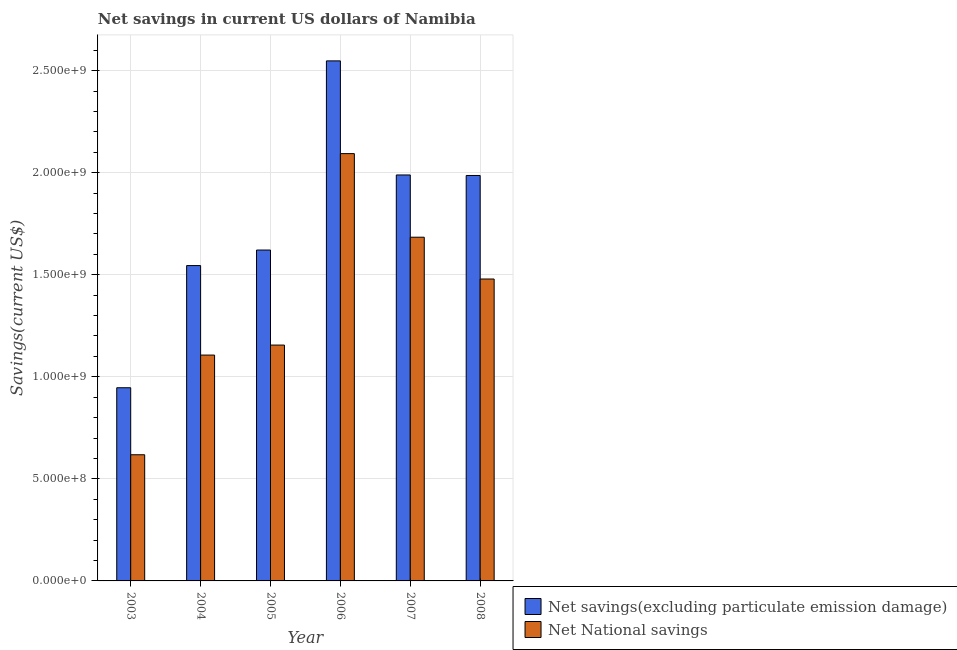How many different coloured bars are there?
Your answer should be compact. 2. Are the number of bars per tick equal to the number of legend labels?
Provide a succinct answer. Yes. How many bars are there on the 5th tick from the right?
Keep it short and to the point. 2. What is the net savings(excluding particulate emission damage) in 2008?
Your response must be concise. 1.99e+09. Across all years, what is the maximum net savings(excluding particulate emission damage)?
Your response must be concise. 2.55e+09. Across all years, what is the minimum net savings(excluding particulate emission damage)?
Give a very brief answer. 9.46e+08. What is the total net national savings in the graph?
Provide a short and direct response. 8.14e+09. What is the difference between the net national savings in 2006 and that in 2008?
Give a very brief answer. 6.14e+08. What is the difference between the net savings(excluding particulate emission damage) in 2008 and the net national savings in 2006?
Your response must be concise. -5.61e+08. What is the average net national savings per year?
Your response must be concise. 1.36e+09. In the year 2003, what is the difference between the net national savings and net savings(excluding particulate emission damage)?
Ensure brevity in your answer.  0. What is the ratio of the net national savings in 2005 to that in 2006?
Provide a short and direct response. 0.55. Is the difference between the net savings(excluding particulate emission damage) in 2003 and 2007 greater than the difference between the net national savings in 2003 and 2007?
Your answer should be very brief. No. What is the difference between the highest and the second highest net national savings?
Offer a very short reply. 4.09e+08. What is the difference between the highest and the lowest net national savings?
Offer a terse response. 1.48e+09. In how many years, is the net national savings greater than the average net national savings taken over all years?
Provide a succinct answer. 3. Is the sum of the net savings(excluding particulate emission damage) in 2007 and 2008 greater than the maximum net national savings across all years?
Make the answer very short. Yes. What does the 1st bar from the left in 2006 represents?
Provide a succinct answer. Net savings(excluding particulate emission damage). What does the 1st bar from the right in 2007 represents?
Make the answer very short. Net National savings. Are all the bars in the graph horizontal?
Keep it short and to the point. No. Are the values on the major ticks of Y-axis written in scientific E-notation?
Your answer should be compact. Yes. Does the graph contain any zero values?
Provide a short and direct response. No. What is the title of the graph?
Your response must be concise. Net savings in current US dollars of Namibia. Does "Food and tobacco" appear as one of the legend labels in the graph?
Your answer should be compact. No. What is the label or title of the Y-axis?
Provide a succinct answer. Savings(current US$). What is the Savings(current US$) of Net savings(excluding particulate emission damage) in 2003?
Your answer should be compact. 9.46e+08. What is the Savings(current US$) in Net National savings in 2003?
Your answer should be very brief. 6.18e+08. What is the Savings(current US$) of Net savings(excluding particulate emission damage) in 2004?
Offer a very short reply. 1.54e+09. What is the Savings(current US$) in Net National savings in 2004?
Your answer should be compact. 1.11e+09. What is the Savings(current US$) in Net savings(excluding particulate emission damage) in 2005?
Your response must be concise. 1.62e+09. What is the Savings(current US$) of Net National savings in 2005?
Your answer should be compact. 1.16e+09. What is the Savings(current US$) in Net savings(excluding particulate emission damage) in 2006?
Keep it short and to the point. 2.55e+09. What is the Savings(current US$) in Net National savings in 2006?
Ensure brevity in your answer.  2.09e+09. What is the Savings(current US$) in Net savings(excluding particulate emission damage) in 2007?
Offer a terse response. 1.99e+09. What is the Savings(current US$) of Net National savings in 2007?
Keep it short and to the point. 1.68e+09. What is the Savings(current US$) in Net savings(excluding particulate emission damage) in 2008?
Provide a succinct answer. 1.99e+09. What is the Savings(current US$) in Net National savings in 2008?
Your answer should be very brief. 1.48e+09. Across all years, what is the maximum Savings(current US$) of Net savings(excluding particulate emission damage)?
Your answer should be compact. 2.55e+09. Across all years, what is the maximum Savings(current US$) in Net National savings?
Offer a very short reply. 2.09e+09. Across all years, what is the minimum Savings(current US$) in Net savings(excluding particulate emission damage)?
Offer a terse response. 9.46e+08. Across all years, what is the minimum Savings(current US$) of Net National savings?
Make the answer very short. 6.18e+08. What is the total Savings(current US$) of Net savings(excluding particulate emission damage) in the graph?
Ensure brevity in your answer.  1.06e+1. What is the total Savings(current US$) in Net National savings in the graph?
Your answer should be very brief. 8.14e+09. What is the difference between the Savings(current US$) in Net savings(excluding particulate emission damage) in 2003 and that in 2004?
Offer a terse response. -5.99e+08. What is the difference between the Savings(current US$) of Net National savings in 2003 and that in 2004?
Give a very brief answer. -4.88e+08. What is the difference between the Savings(current US$) of Net savings(excluding particulate emission damage) in 2003 and that in 2005?
Make the answer very short. -6.75e+08. What is the difference between the Savings(current US$) of Net National savings in 2003 and that in 2005?
Offer a terse response. -5.37e+08. What is the difference between the Savings(current US$) in Net savings(excluding particulate emission damage) in 2003 and that in 2006?
Make the answer very short. -1.60e+09. What is the difference between the Savings(current US$) in Net National savings in 2003 and that in 2006?
Offer a very short reply. -1.48e+09. What is the difference between the Savings(current US$) in Net savings(excluding particulate emission damage) in 2003 and that in 2007?
Provide a short and direct response. -1.04e+09. What is the difference between the Savings(current US$) in Net National savings in 2003 and that in 2007?
Your answer should be very brief. -1.07e+09. What is the difference between the Savings(current US$) of Net savings(excluding particulate emission damage) in 2003 and that in 2008?
Your response must be concise. -1.04e+09. What is the difference between the Savings(current US$) in Net National savings in 2003 and that in 2008?
Your response must be concise. -8.61e+08. What is the difference between the Savings(current US$) of Net savings(excluding particulate emission damage) in 2004 and that in 2005?
Ensure brevity in your answer.  -7.61e+07. What is the difference between the Savings(current US$) in Net National savings in 2004 and that in 2005?
Offer a terse response. -4.90e+07. What is the difference between the Savings(current US$) in Net savings(excluding particulate emission damage) in 2004 and that in 2006?
Provide a short and direct response. -1.00e+09. What is the difference between the Savings(current US$) in Net National savings in 2004 and that in 2006?
Give a very brief answer. -9.87e+08. What is the difference between the Savings(current US$) of Net savings(excluding particulate emission damage) in 2004 and that in 2007?
Keep it short and to the point. -4.44e+08. What is the difference between the Savings(current US$) in Net National savings in 2004 and that in 2007?
Your response must be concise. -5.77e+08. What is the difference between the Savings(current US$) in Net savings(excluding particulate emission damage) in 2004 and that in 2008?
Make the answer very short. -4.41e+08. What is the difference between the Savings(current US$) of Net National savings in 2004 and that in 2008?
Keep it short and to the point. -3.73e+08. What is the difference between the Savings(current US$) of Net savings(excluding particulate emission damage) in 2005 and that in 2006?
Offer a terse response. -9.27e+08. What is the difference between the Savings(current US$) in Net National savings in 2005 and that in 2006?
Make the answer very short. -9.38e+08. What is the difference between the Savings(current US$) in Net savings(excluding particulate emission damage) in 2005 and that in 2007?
Your answer should be very brief. -3.68e+08. What is the difference between the Savings(current US$) of Net National savings in 2005 and that in 2007?
Make the answer very short. -5.28e+08. What is the difference between the Savings(current US$) in Net savings(excluding particulate emission damage) in 2005 and that in 2008?
Your answer should be very brief. -3.65e+08. What is the difference between the Savings(current US$) of Net National savings in 2005 and that in 2008?
Make the answer very short. -3.24e+08. What is the difference between the Savings(current US$) of Net savings(excluding particulate emission damage) in 2006 and that in 2007?
Provide a succinct answer. 5.59e+08. What is the difference between the Savings(current US$) in Net National savings in 2006 and that in 2007?
Give a very brief answer. 4.09e+08. What is the difference between the Savings(current US$) in Net savings(excluding particulate emission damage) in 2006 and that in 2008?
Offer a very short reply. 5.61e+08. What is the difference between the Savings(current US$) in Net National savings in 2006 and that in 2008?
Offer a terse response. 6.14e+08. What is the difference between the Savings(current US$) in Net savings(excluding particulate emission damage) in 2007 and that in 2008?
Provide a succinct answer. 2.53e+06. What is the difference between the Savings(current US$) in Net National savings in 2007 and that in 2008?
Provide a succinct answer. 2.05e+08. What is the difference between the Savings(current US$) of Net savings(excluding particulate emission damage) in 2003 and the Savings(current US$) of Net National savings in 2004?
Give a very brief answer. -1.60e+08. What is the difference between the Savings(current US$) in Net savings(excluding particulate emission damage) in 2003 and the Savings(current US$) in Net National savings in 2005?
Your answer should be very brief. -2.09e+08. What is the difference between the Savings(current US$) of Net savings(excluding particulate emission damage) in 2003 and the Savings(current US$) of Net National savings in 2006?
Provide a short and direct response. -1.15e+09. What is the difference between the Savings(current US$) of Net savings(excluding particulate emission damage) in 2003 and the Savings(current US$) of Net National savings in 2007?
Provide a succinct answer. -7.37e+08. What is the difference between the Savings(current US$) in Net savings(excluding particulate emission damage) in 2003 and the Savings(current US$) in Net National savings in 2008?
Give a very brief answer. -5.33e+08. What is the difference between the Savings(current US$) in Net savings(excluding particulate emission damage) in 2004 and the Savings(current US$) in Net National savings in 2005?
Your answer should be compact. 3.89e+08. What is the difference between the Savings(current US$) in Net savings(excluding particulate emission damage) in 2004 and the Savings(current US$) in Net National savings in 2006?
Ensure brevity in your answer.  -5.48e+08. What is the difference between the Savings(current US$) in Net savings(excluding particulate emission damage) in 2004 and the Savings(current US$) in Net National savings in 2007?
Give a very brief answer. -1.39e+08. What is the difference between the Savings(current US$) in Net savings(excluding particulate emission damage) in 2004 and the Savings(current US$) in Net National savings in 2008?
Make the answer very short. 6.59e+07. What is the difference between the Savings(current US$) of Net savings(excluding particulate emission damage) in 2005 and the Savings(current US$) of Net National savings in 2006?
Keep it short and to the point. -4.72e+08. What is the difference between the Savings(current US$) of Net savings(excluding particulate emission damage) in 2005 and the Savings(current US$) of Net National savings in 2007?
Make the answer very short. -6.29e+07. What is the difference between the Savings(current US$) in Net savings(excluding particulate emission damage) in 2005 and the Savings(current US$) in Net National savings in 2008?
Give a very brief answer. 1.42e+08. What is the difference between the Savings(current US$) in Net savings(excluding particulate emission damage) in 2006 and the Savings(current US$) in Net National savings in 2007?
Give a very brief answer. 8.64e+08. What is the difference between the Savings(current US$) in Net savings(excluding particulate emission damage) in 2006 and the Savings(current US$) in Net National savings in 2008?
Your answer should be compact. 1.07e+09. What is the difference between the Savings(current US$) of Net savings(excluding particulate emission damage) in 2007 and the Savings(current US$) of Net National savings in 2008?
Make the answer very short. 5.10e+08. What is the average Savings(current US$) of Net savings(excluding particulate emission damage) per year?
Your answer should be very brief. 1.77e+09. What is the average Savings(current US$) of Net National savings per year?
Offer a terse response. 1.36e+09. In the year 2003, what is the difference between the Savings(current US$) of Net savings(excluding particulate emission damage) and Savings(current US$) of Net National savings?
Your response must be concise. 3.28e+08. In the year 2004, what is the difference between the Savings(current US$) in Net savings(excluding particulate emission damage) and Savings(current US$) in Net National savings?
Ensure brevity in your answer.  4.38e+08. In the year 2005, what is the difference between the Savings(current US$) of Net savings(excluding particulate emission damage) and Savings(current US$) of Net National savings?
Make the answer very short. 4.66e+08. In the year 2006, what is the difference between the Savings(current US$) of Net savings(excluding particulate emission damage) and Savings(current US$) of Net National savings?
Provide a short and direct response. 4.54e+08. In the year 2007, what is the difference between the Savings(current US$) of Net savings(excluding particulate emission damage) and Savings(current US$) of Net National savings?
Your answer should be very brief. 3.05e+08. In the year 2008, what is the difference between the Savings(current US$) of Net savings(excluding particulate emission damage) and Savings(current US$) of Net National savings?
Make the answer very short. 5.07e+08. What is the ratio of the Savings(current US$) of Net savings(excluding particulate emission damage) in 2003 to that in 2004?
Your answer should be compact. 0.61. What is the ratio of the Savings(current US$) of Net National savings in 2003 to that in 2004?
Make the answer very short. 0.56. What is the ratio of the Savings(current US$) in Net savings(excluding particulate emission damage) in 2003 to that in 2005?
Give a very brief answer. 0.58. What is the ratio of the Savings(current US$) of Net National savings in 2003 to that in 2005?
Offer a very short reply. 0.54. What is the ratio of the Savings(current US$) of Net savings(excluding particulate emission damage) in 2003 to that in 2006?
Provide a succinct answer. 0.37. What is the ratio of the Savings(current US$) of Net National savings in 2003 to that in 2006?
Make the answer very short. 0.3. What is the ratio of the Savings(current US$) in Net savings(excluding particulate emission damage) in 2003 to that in 2007?
Ensure brevity in your answer.  0.48. What is the ratio of the Savings(current US$) of Net National savings in 2003 to that in 2007?
Make the answer very short. 0.37. What is the ratio of the Savings(current US$) of Net savings(excluding particulate emission damage) in 2003 to that in 2008?
Your answer should be very brief. 0.48. What is the ratio of the Savings(current US$) of Net National savings in 2003 to that in 2008?
Ensure brevity in your answer.  0.42. What is the ratio of the Savings(current US$) of Net savings(excluding particulate emission damage) in 2004 to that in 2005?
Give a very brief answer. 0.95. What is the ratio of the Savings(current US$) in Net National savings in 2004 to that in 2005?
Your answer should be compact. 0.96. What is the ratio of the Savings(current US$) in Net savings(excluding particulate emission damage) in 2004 to that in 2006?
Offer a very short reply. 0.61. What is the ratio of the Savings(current US$) in Net National savings in 2004 to that in 2006?
Make the answer very short. 0.53. What is the ratio of the Savings(current US$) of Net savings(excluding particulate emission damage) in 2004 to that in 2007?
Your response must be concise. 0.78. What is the ratio of the Savings(current US$) in Net National savings in 2004 to that in 2007?
Your answer should be very brief. 0.66. What is the ratio of the Savings(current US$) in Net savings(excluding particulate emission damage) in 2004 to that in 2008?
Your response must be concise. 0.78. What is the ratio of the Savings(current US$) in Net National savings in 2004 to that in 2008?
Give a very brief answer. 0.75. What is the ratio of the Savings(current US$) in Net savings(excluding particulate emission damage) in 2005 to that in 2006?
Offer a very short reply. 0.64. What is the ratio of the Savings(current US$) in Net National savings in 2005 to that in 2006?
Provide a succinct answer. 0.55. What is the ratio of the Savings(current US$) in Net savings(excluding particulate emission damage) in 2005 to that in 2007?
Provide a short and direct response. 0.82. What is the ratio of the Savings(current US$) of Net National savings in 2005 to that in 2007?
Provide a succinct answer. 0.69. What is the ratio of the Savings(current US$) in Net savings(excluding particulate emission damage) in 2005 to that in 2008?
Offer a terse response. 0.82. What is the ratio of the Savings(current US$) in Net National savings in 2005 to that in 2008?
Offer a very short reply. 0.78. What is the ratio of the Savings(current US$) of Net savings(excluding particulate emission damage) in 2006 to that in 2007?
Keep it short and to the point. 1.28. What is the ratio of the Savings(current US$) of Net National savings in 2006 to that in 2007?
Your response must be concise. 1.24. What is the ratio of the Savings(current US$) in Net savings(excluding particulate emission damage) in 2006 to that in 2008?
Ensure brevity in your answer.  1.28. What is the ratio of the Savings(current US$) in Net National savings in 2006 to that in 2008?
Provide a succinct answer. 1.42. What is the ratio of the Savings(current US$) in Net savings(excluding particulate emission damage) in 2007 to that in 2008?
Provide a short and direct response. 1. What is the ratio of the Savings(current US$) of Net National savings in 2007 to that in 2008?
Your answer should be very brief. 1.14. What is the difference between the highest and the second highest Savings(current US$) in Net savings(excluding particulate emission damage)?
Your answer should be very brief. 5.59e+08. What is the difference between the highest and the second highest Savings(current US$) of Net National savings?
Keep it short and to the point. 4.09e+08. What is the difference between the highest and the lowest Savings(current US$) of Net savings(excluding particulate emission damage)?
Offer a very short reply. 1.60e+09. What is the difference between the highest and the lowest Savings(current US$) of Net National savings?
Offer a very short reply. 1.48e+09. 